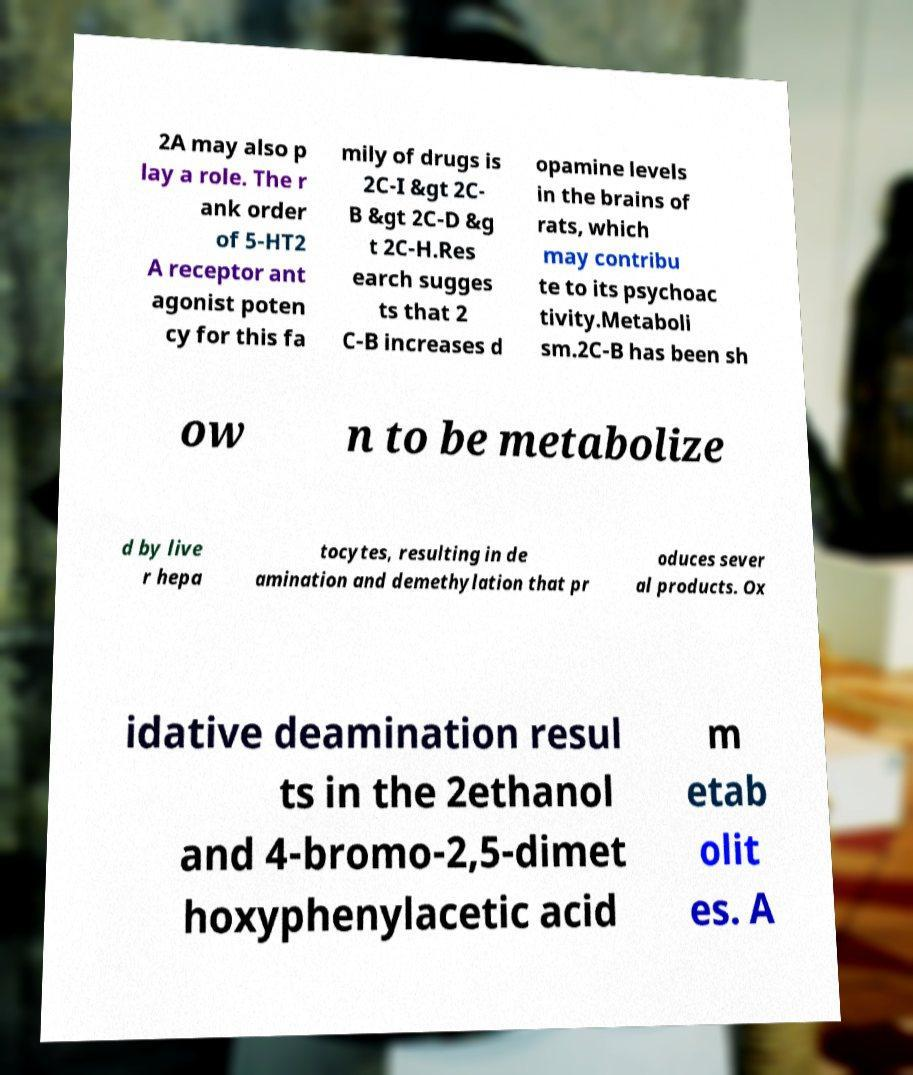Can you accurately transcribe the text from the provided image for me? 2A may also p lay a role. The r ank order of 5-HT2 A receptor ant agonist poten cy for this fa mily of drugs is 2C-I &gt 2C- B &gt 2C-D &g t 2C-H.Res earch sugges ts that 2 C-B increases d opamine levels in the brains of rats, which may contribu te to its psychoac tivity.Metaboli sm.2C-B has been sh ow n to be metabolize d by live r hepa tocytes, resulting in de amination and demethylation that pr oduces sever al products. Ox idative deamination resul ts in the 2ethanol and 4-bromo-2,5-dimet hoxyphenylacetic acid m etab olit es. A 